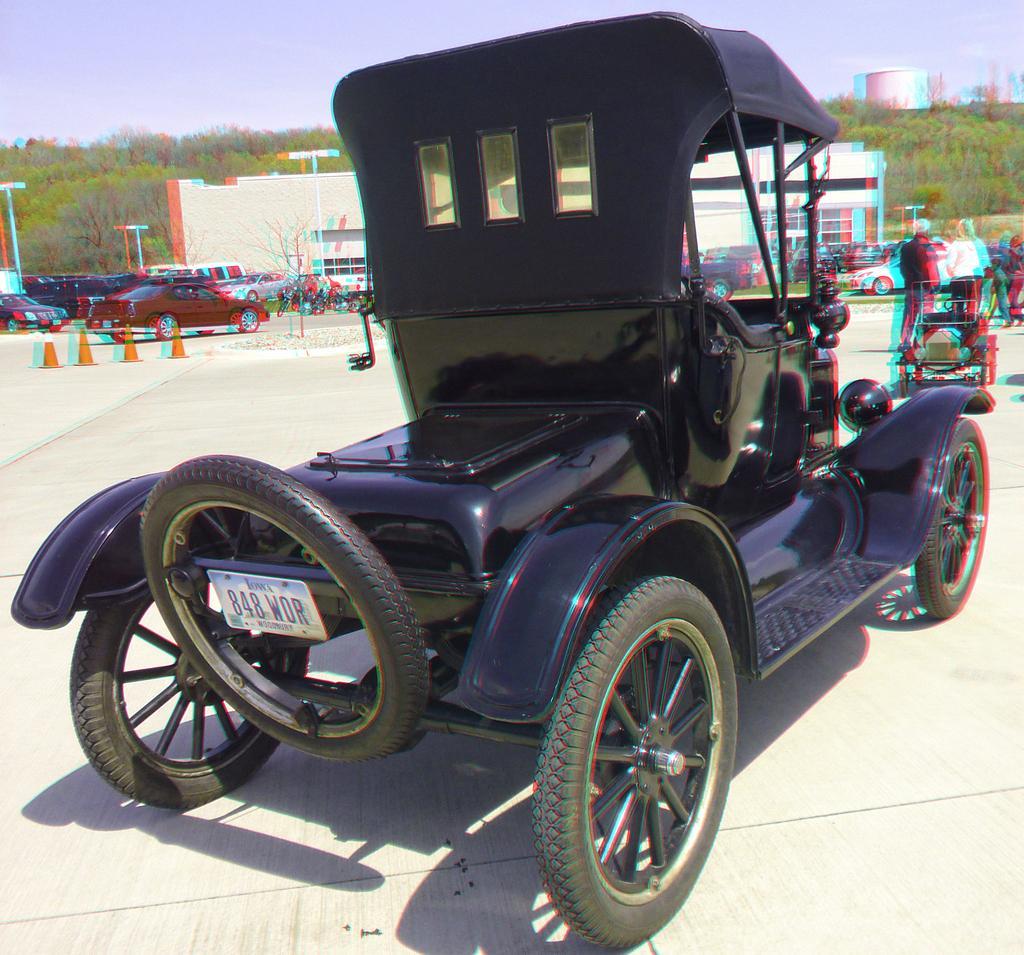How would you summarize this image in a sentence or two? In this picture there is a black color vehicle and there are few persons standing in the right corner and there are few vehicles,buildings and trees in the background. 